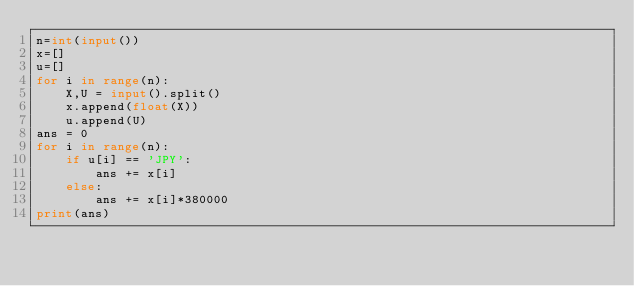Convert code to text. <code><loc_0><loc_0><loc_500><loc_500><_Python_>n=int(input())
x=[]
u=[]
for i in range(n):
    X,U = input().split()
    x.append(float(X))
    u.append(U)
ans = 0
for i in range(n):
    if u[i] == 'JPY':
        ans += x[i]
    else:
        ans += x[i]*380000
print(ans)
</code> 